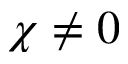<formula> <loc_0><loc_0><loc_500><loc_500>\chi \neq 0</formula> 